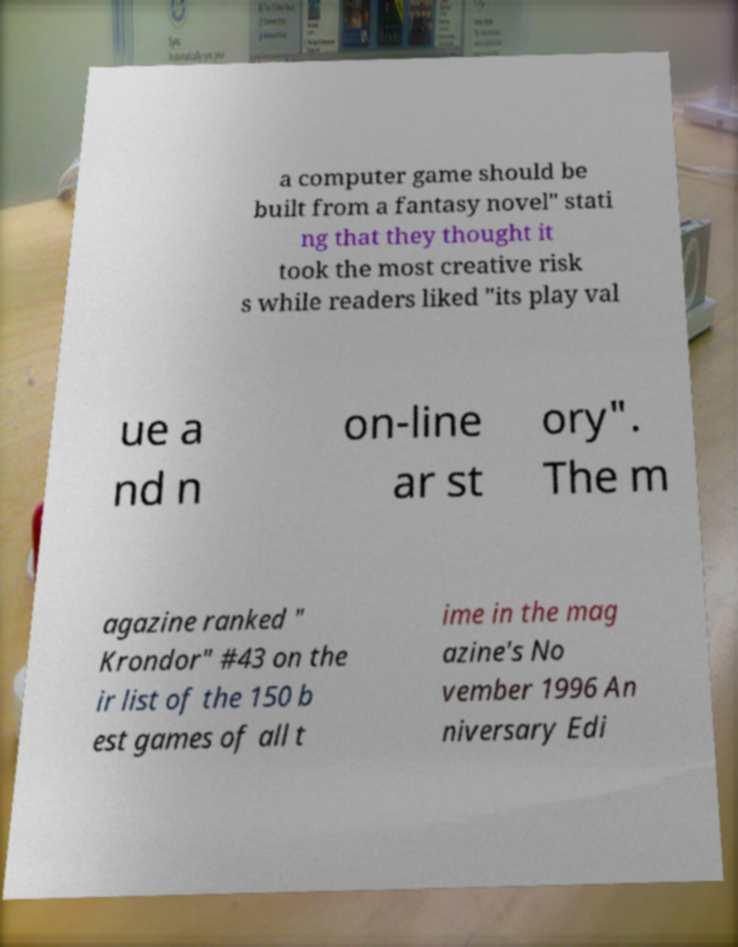I need the written content from this picture converted into text. Can you do that? a computer game should be built from a fantasy novel" stati ng that they thought it took the most creative risk s while readers liked "its play val ue a nd n on-line ar st ory". The m agazine ranked " Krondor" #43 on the ir list of the 150 b est games of all t ime in the mag azine's No vember 1996 An niversary Edi 